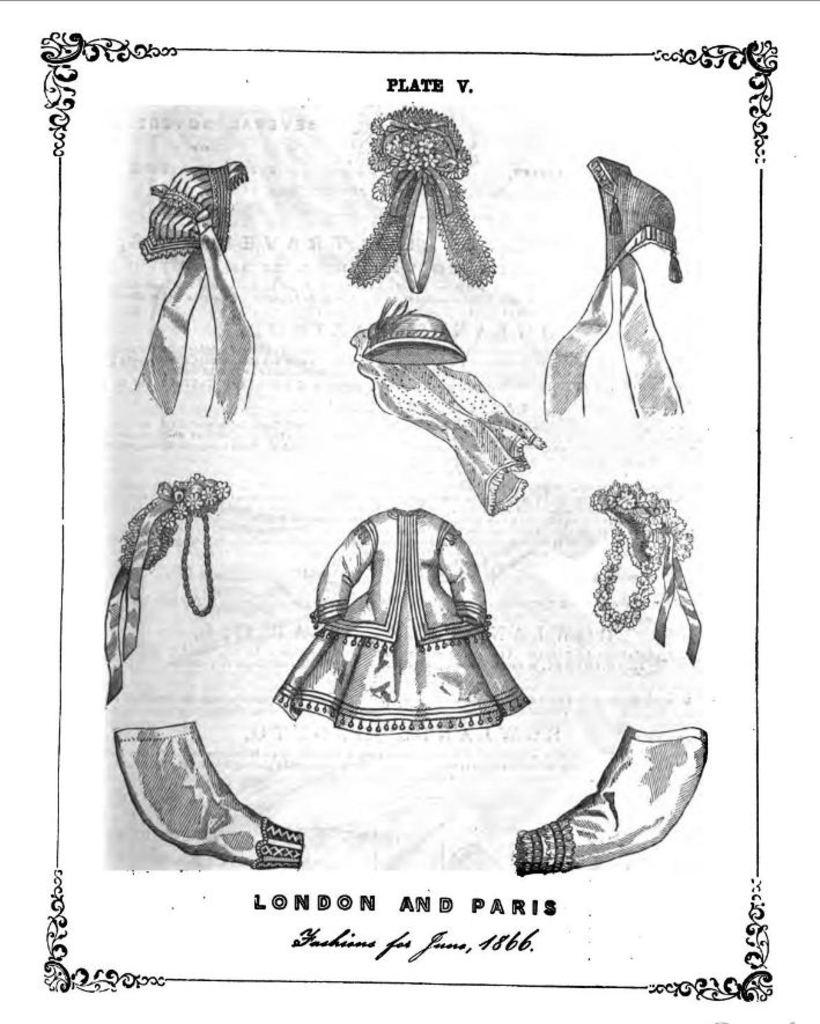What is depicted in the image? The image contains a drawing of clothes and accessories. Are there any design elements that stand out in the image? Yes, there are borders in the image. Is there any text or information provided in the image? Some matter is written at the bottom of the image. What is the color scheme of the image? The image is black and white. Can you see a person wearing the clothes depicted in the image? There is no person present in the image; it contains a drawing of clothes and accessories. Are there any stems visible in the image? There are no stems present in the image; it is a drawing of clothes and accessories with borders and written matter at the bottom. 